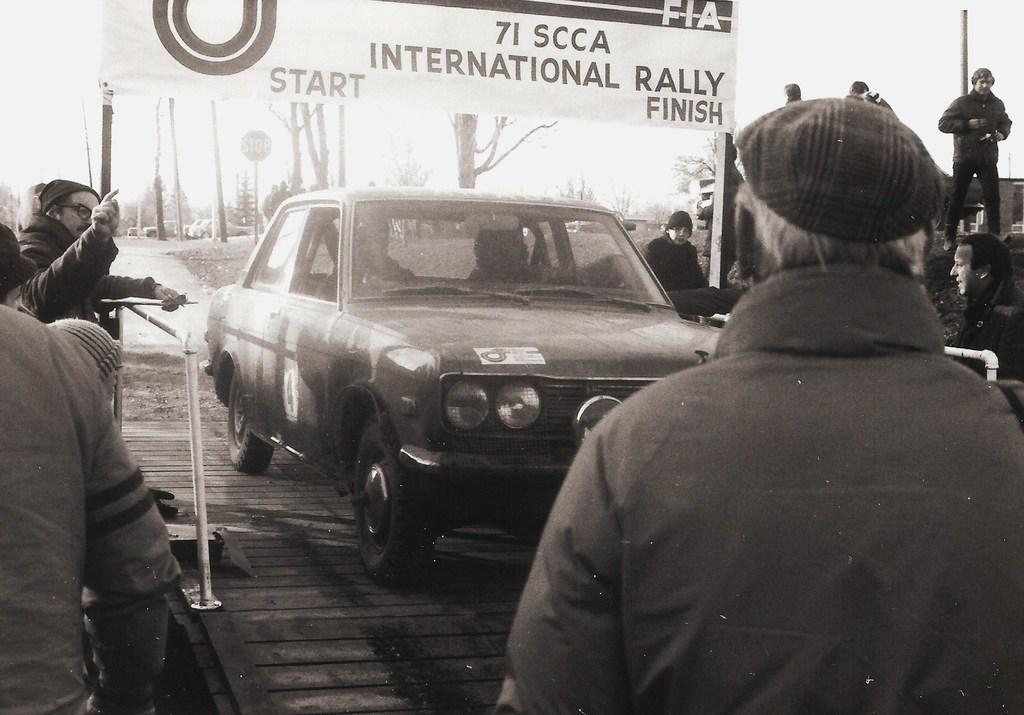What is the main subject in the middle of the image? There is a car in the middle of the image. Who or what is on the right side of the image? A person is standing on the right side of the image. What is the person wearing on their head? The person is wearing a cap. What can be seen on the left side of the image? There are people standing on the left side of the image. What type of house is visible in the background of the image? There is no house visible in the background of the image. What kind of pump is being used by the person on the right side of the image? There is no pump present in the image; the person is simply standing with a cap on their head. 